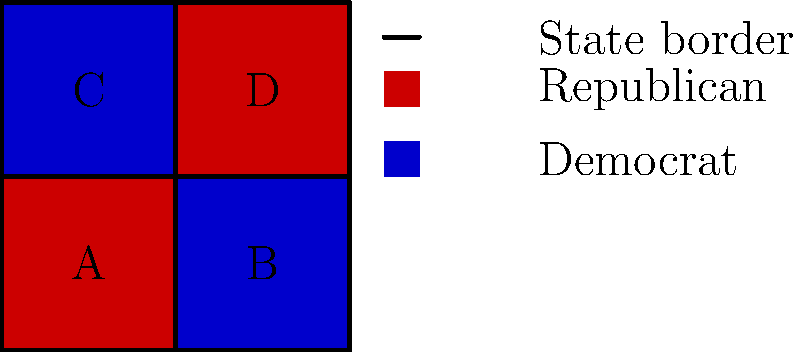Analyze the color-coded map representing voting patterns in a hypothetical country divided into four states (A, B, C, and D). What political phenomenon does this map likely illustrate, and how might it impact national election strategies? To answer this question, let's analyze the map step-by-step:

1. Color distribution:
   - States A and D are colored red
   - States B and C are colored blue

2. Political party association:
   - Red typically represents the Republican party in US politics
   - Blue typically represents the Democratic party in US politics

3. Geographical pattern:
   - The colors alternate in a checkered pattern
   - There's no clear regional dominance for either party

4. Political phenomenon:
   This map likely illustrates political polarization at the state level, specifically a phenomenon known as the "red state-blue state divide."

5. Implications for national election strategies:
   a) Candidates may focus on swing states or states with close margins to maximize electoral college votes.
   b) Parties might employ different strategies for urban vs. rural areas within each state.
   c) Coalition-building across state lines could be crucial for winning national elections.
   d) Campaigns may need to address diverse issues to appeal to voters in different states.

6. Electoral college considerations:
   - Assuming equal population and electoral votes per state, this map suggests a tied election (2 red states vs. 2 blue states).
   - In reality, states often have different populations and electoral vote allocations, which would need to be considered.

7. Historical context:
   This pattern is reminiscent of the increasing political polarization in the United States since the late 20th century, where states have become more consistently aligned with one party or the other in presidential elections.
Answer: The map illustrates the "red state-blue state divide," showcasing political polarization at the state level. This phenomenon would likely lead to focused campaigning in potential swing states and the development of strategies to appeal to diverse voter bases across state lines. 